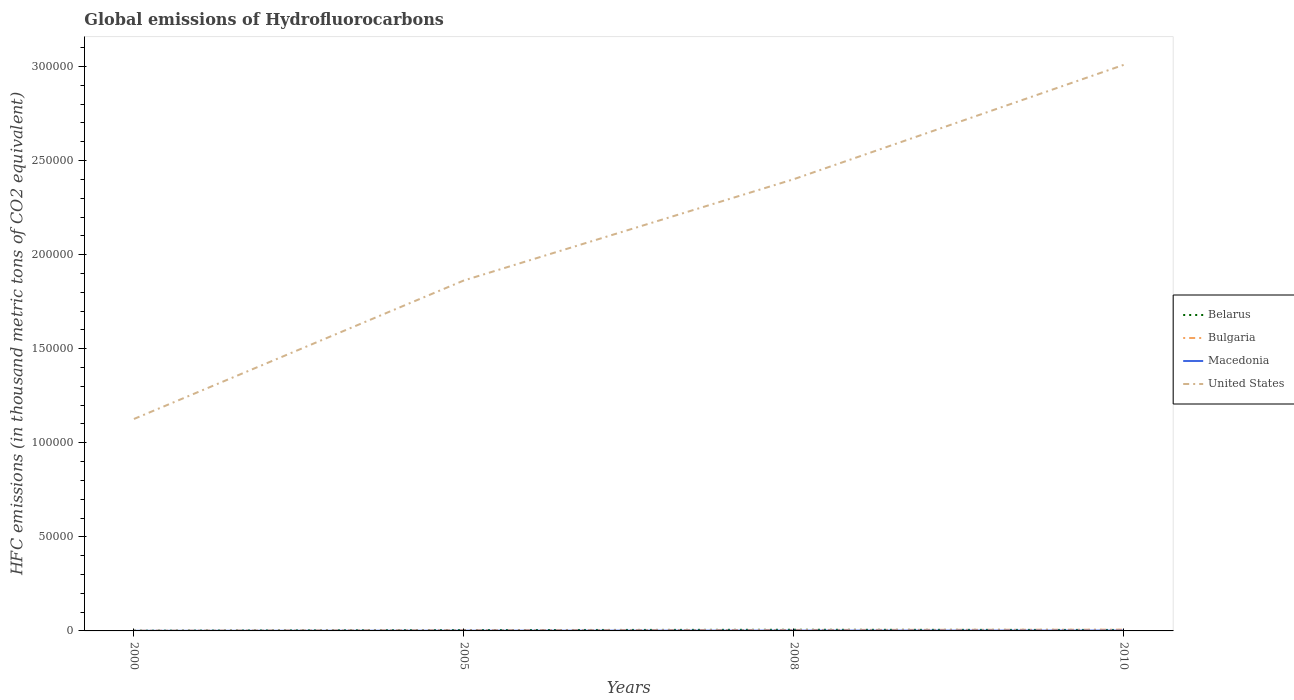How many different coloured lines are there?
Your response must be concise. 4. Across all years, what is the maximum global emissions of Hydrofluorocarbons in Bulgaria?
Provide a short and direct response. 103.1. What is the total global emissions of Hydrofluorocarbons in Macedonia in the graph?
Keep it short and to the point. -133.2. What is the difference between the highest and the second highest global emissions of Hydrofluorocarbons in Macedonia?
Make the answer very short. 133.2. What is the difference between the highest and the lowest global emissions of Hydrofluorocarbons in Belarus?
Make the answer very short. 3. Is the global emissions of Hydrofluorocarbons in United States strictly greater than the global emissions of Hydrofluorocarbons in Macedonia over the years?
Make the answer very short. No. How many years are there in the graph?
Your answer should be compact. 4. Are the values on the major ticks of Y-axis written in scientific E-notation?
Provide a succinct answer. No. Does the graph contain grids?
Ensure brevity in your answer.  No. How are the legend labels stacked?
Your response must be concise. Vertical. What is the title of the graph?
Your answer should be compact. Global emissions of Hydrofluorocarbons. What is the label or title of the X-axis?
Your response must be concise. Years. What is the label or title of the Y-axis?
Your answer should be very brief. HFC emissions (in thousand metric tons of CO2 equivalent). What is the HFC emissions (in thousand metric tons of CO2 equivalent) of Belarus in 2000?
Provide a short and direct response. 107.7. What is the HFC emissions (in thousand metric tons of CO2 equivalent) in Bulgaria in 2000?
Make the answer very short. 103.1. What is the HFC emissions (in thousand metric tons of CO2 equivalent) in Macedonia in 2000?
Offer a terse response. 51.8. What is the HFC emissions (in thousand metric tons of CO2 equivalent) of United States in 2000?
Give a very brief answer. 1.13e+05. What is the HFC emissions (in thousand metric tons of CO2 equivalent) of Belarus in 2005?
Offer a terse response. 440.2. What is the HFC emissions (in thousand metric tons of CO2 equivalent) in Bulgaria in 2005?
Your answer should be very brief. 361.6. What is the HFC emissions (in thousand metric tons of CO2 equivalent) of Macedonia in 2005?
Your answer should be compact. 119.1. What is the HFC emissions (in thousand metric tons of CO2 equivalent) of United States in 2005?
Keep it short and to the point. 1.86e+05. What is the HFC emissions (in thousand metric tons of CO2 equivalent) in Belarus in 2008?
Your response must be concise. 612.1. What is the HFC emissions (in thousand metric tons of CO2 equivalent) of Bulgaria in 2008?
Your answer should be very brief. 508. What is the HFC emissions (in thousand metric tons of CO2 equivalent) of Macedonia in 2008?
Offer a very short reply. 157.6. What is the HFC emissions (in thousand metric tons of CO2 equivalent) of United States in 2008?
Make the answer very short. 2.40e+05. What is the HFC emissions (in thousand metric tons of CO2 equivalent) in Belarus in 2010?
Your answer should be compact. 516. What is the HFC emissions (in thousand metric tons of CO2 equivalent) of Bulgaria in 2010?
Offer a terse response. 648. What is the HFC emissions (in thousand metric tons of CO2 equivalent) of Macedonia in 2010?
Your answer should be compact. 185. What is the HFC emissions (in thousand metric tons of CO2 equivalent) in United States in 2010?
Ensure brevity in your answer.  3.01e+05. Across all years, what is the maximum HFC emissions (in thousand metric tons of CO2 equivalent) of Belarus?
Your answer should be compact. 612.1. Across all years, what is the maximum HFC emissions (in thousand metric tons of CO2 equivalent) of Bulgaria?
Your answer should be very brief. 648. Across all years, what is the maximum HFC emissions (in thousand metric tons of CO2 equivalent) in Macedonia?
Ensure brevity in your answer.  185. Across all years, what is the maximum HFC emissions (in thousand metric tons of CO2 equivalent) in United States?
Keep it short and to the point. 3.01e+05. Across all years, what is the minimum HFC emissions (in thousand metric tons of CO2 equivalent) of Belarus?
Provide a short and direct response. 107.7. Across all years, what is the minimum HFC emissions (in thousand metric tons of CO2 equivalent) of Bulgaria?
Your answer should be very brief. 103.1. Across all years, what is the minimum HFC emissions (in thousand metric tons of CO2 equivalent) of Macedonia?
Your answer should be compact. 51.8. Across all years, what is the minimum HFC emissions (in thousand metric tons of CO2 equivalent) in United States?
Ensure brevity in your answer.  1.13e+05. What is the total HFC emissions (in thousand metric tons of CO2 equivalent) of Belarus in the graph?
Your answer should be very brief. 1676. What is the total HFC emissions (in thousand metric tons of CO2 equivalent) of Bulgaria in the graph?
Offer a very short reply. 1620.7. What is the total HFC emissions (in thousand metric tons of CO2 equivalent) of Macedonia in the graph?
Ensure brevity in your answer.  513.5. What is the total HFC emissions (in thousand metric tons of CO2 equivalent) in United States in the graph?
Offer a terse response. 8.40e+05. What is the difference between the HFC emissions (in thousand metric tons of CO2 equivalent) of Belarus in 2000 and that in 2005?
Provide a succinct answer. -332.5. What is the difference between the HFC emissions (in thousand metric tons of CO2 equivalent) in Bulgaria in 2000 and that in 2005?
Provide a short and direct response. -258.5. What is the difference between the HFC emissions (in thousand metric tons of CO2 equivalent) of Macedonia in 2000 and that in 2005?
Your answer should be very brief. -67.3. What is the difference between the HFC emissions (in thousand metric tons of CO2 equivalent) of United States in 2000 and that in 2005?
Give a very brief answer. -7.36e+04. What is the difference between the HFC emissions (in thousand metric tons of CO2 equivalent) in Belarus in 2000 and that in 2008?
Provide a short and direct response. -504.4. What is the difference between the HFC emissions (in thousand metric tons of CO2 equivalent) in Bulgaria in 2000 and that in 2008?
Offer a terse response. -404.9. What is the difference between the HFC emissions (in thousand metric tons of CO2 equivalent) of Macedonia in 2000 and that in 2008?
Your answer should be compact. -105.8. What is the difference between the HFC emissions (in thousand metric tons of CO2 equivalent) in United States in 2000 and that in 2008?
Your answer should be very brief. -1.27e+05. What is the difference between the HFC emissions (in thousand metric tons of CO2 equivalent) in Belarus in 2000 and that in 2010?
Your response must be concise. -408.3. What is the difference between the HFC emissions (in thousand metric tons of CO2 equivalent) in Bulgaria in 2000 and that in 2010?
Give a very brief answer. -544.9. What is the difference between the HFC emissions (in thousand metric tons of CO2 equivalent) in Macedonia in 2000 and that in 2010?
Your answer should be very brief. -133.2. What is the difference between the HFC emissions (in thousand metric tons of CO2 equivalent) of United States in 2000 and that in 2010?
Provide a succinct answer. -1.88e+05. What is the difference between the HFC emissions (in thousand metric tons of CO2 equivalent) of Belarus in 2005 and that in 2008?
Offer a very short reply. -171.9. What is the difference between the HFC emissions (in thousand metric tons of CO2 equivalent) in Bulgaria in 2005 and that in 2008?
Provide a succinct answer. -146.4. What is the difference between the HFC emissions (in thousand metric tons of CO2 equivalent) of Macedonia in 2005 and that in 2008?
Provide a succinct answer. -38.5. What is the difference between the HFC emissions (in thousand metric tons of CO2 equivalent) of United States in 2005 and that in 2008?
Keep it short and to the point. -5.38e+04. What is the difference between the HFC emissions (in thousand metric tons of CO2 equivalent) in Belarus in 2005 and that in 2010?
Offer a very short reply. -75.8. What is the difference between the HFC emissions (in thousand metric tons of CO2 equivalent) of Bulgaria in 2005 and that in 2010?
Your response must be concise. -286.4. What is the difference between the HFC emissions (in thousand metric tons of CO2 equivalent) of Macedonia in 2005 and that in 2010?
Keep it short and to the point. -65.9. What is the difference between the HFC emissions (in thousand metric tons of CO2 equivalent) in United States in 2005 and that in 2010?
Your answer should be compact. -1.15e+05. What is the difference between the HFC emissions (in thousand metric tons of CO2 equivalent) in Belarus in 2008 and that in 2010?
Provide a succinct answer. 96.1. What is the difference between the HFC emissions (in thousand metric tons of CO2 equivalent) in Bulgaria in 2008 and that in 2010?
Your answer should be very brief. -140. What is the difference between the HFC emissions (in thousand metric tons of CO2 equivalent) of Macedonia in 2008 and that in 2010?
Provide a short and direct response. -27.4. What is the difference between the HFC emissions (in thousand metric tons of CO2 equivalent) in United States in 2008 and that in 2010?
Provide a succinct answer. -6.08e+04. What is the difference between the HFC emissions (in thousand metric tons of CO2 equivalent) of Belarus in 2000 and the HFC emissions (in thousand metric tons of CO2 equivalent) of Bulgaria in 2005?
Keep it short and to the point. -253.9. What is the difference between the HFC emissions (in thousand metric tons of CO2 equivalent) of Belarus in 2000 and the HFC emissions (in thousand metric tons of CO2 equivalent) of Macedonia in 2005?
Keep it short and to the point. -11.4. What is the difference between the HFC emissions (in thousand metric tons of CO2 equivalent) of Belarus in 2000 and the HFC emissions (in thousand metric tons of CO2 equivalent) of United States in 2005?
Offer a very short reply. -1.86e+05. What is the difference between the HFC emissions (in thousand metric tons of CO2 equivalent) of Bulgaria in 2000 and the HFC emissions (in thousand metric tons of CO2 equivalent) of United States in 2005?
Keep it short and to the point. -1.86e+05. What is the difference between the HFC emissions (in thousand metric tons of CO2 equivalent) of Macedonia in 2000 and the HFC emissions (in thousand metric tons of CO2 equivalent) of United States in 2005?
Give a very brief answer. -1.86e+05. What is the difference between the HFC emissions (in thousand metric tons of CO2 equivalent) of Belarus in 2000 and the HFC emissions (in thousand metric tons of CO2 equivalent) of Bulgaria in 2008?
Provide a succinct answer. -400.3. What is the difference between the HFC emissions (in thousand metric tons of CO2 equivalent) of Belarus in 2000 and the HFC emissions (in thousand metric tons of CO2 equivalent) of Macedonia in 2008?
Provide a succinct answer. -49.9. What is the difference between the HFC emissions (in thousand metric tons of CO2 equivalent) of Belarus in 2000 and the HFC emissions (in thousand metric tons of CO2 equivalent) of United States in 2008?
Your answer should be very brief. -2.40e+05. What is the difference between the HFC emissions (in thousand metric tons of CO2 equivalent) of Bulgaria in 2000 and the HFC emissions (in thousand metric tons of CO2 equivalent) of Macedonia in 2008?
Provide a succinct answer. -54.5. What is the difference between the HFC emissions (in thousand metric tons of CO2 equivalent) in Bulgaria in 2000 and the HFC emissions (in thousand metric tons of CO2 equivalent) in United States in 2008?
Provide a short and direct response. -2.40e+05. What is the difference between the HFC emissions (in thousand metric tons of CO2 equivalent) of Macedonia in 2000 and the HFC emissions (in thousand metric tons of CO2 equivalent) of United States in 2008?
Make the answer very short. -2.40e+05. What is the difference between the HFC emissions (in thousand metric tons of CO2 equivalent) of Belarus in 2000 and the HFC emissions (in thousand metric tons of CO2 equivalent) of Bulgaria in 2010?
Provide a short and direct response. -540.3. What is the difference between the HFC emissions (in thousand metric tons of CO2 equivalent) in Belarus in 2000 and the HFC emissions (in thousand metric tons of CO2 equivalent) in Macedonia in 2010?
Provide a short and direct response. -77.3. What is the difference between the HFC emissions (in thousand metric tons of CO2 equivalent) of Belarus in 2000 and the HFC emissions (in thousand metric tons of CO2 equivalent) of United States in 2010?
Provide a succinct answer. -3.01e+05. What is the difference between the HFC emissions (in thousand metric tons of CO2 equivalent) in Bulgaria in 2000 and the HFC emissions (in thousand metric tons of CO2 equivalent) in Macedonia in 2010?
Keep it short and to the point. -81.9. What is the difference between the HFC emissions (in thousand metric tons of CO2 equivalent) of Bulgaria in 2000 and the HFC emissions (in thousand metric tons of CO2 equivalent) of United States in 2010?
Offer a terse response. -3.01e+05. What is the difference between the HFC emissions (in thousand metric tons of CO2 equivalent) in Macedonia in 2000 and the HFC emissions (in thousand metric tons of CO2 equivalent) in United States in 2010?
Provide a short and direct response. -3.01e+05. What is the difference between the HFC emissions (in thousand metric tons of CO2 equivalent) in Belarus in 2005 and the HFC emissions (in thousand metric tons of CO2 equivalent) in Bulgaria in 2008?
Provide a succinct answer. -67.8. What is the difference between the HFC emissions (in thousand metric tons of CO2 equivalent) in Belarus in 2005 and the HFC emissions (in thousand metric tons of CO2 equivalent) in Macedonia in 2008?
Provide a short and direct response. 282.6. What is the difference between the HFC emissions (in thousand metric tons of CO2 equivalent) in Belarus in 2005 and the HFC emissions (in thousand metric tons of CO2 equivalent) in United States in 2008?
Ensure brevity in your answer.  -2.40e+05. What is the difference between the HFC emissions (in thousand metric tons of CO2 equivalent) of Bulgaria in 2005 and the HFC emissions (in thousand metric tons of CO2 equivalent) of Macedonia in 2008?
Offer a terse response. 204. What is the difference between the HFC emissions (in thousand metric tons of CO2 equivalent) in Bulgaria in 2005 and the HFC emissions (in thousand metric tons of CO2 equivalent) in United States in 2008?
Ensure brevity in your answer.  -2.40e+05. What is the difference between the HFC emissions (in thousand metric tons of CO2 equivalent) of Macedonia in 2005 and the HFC emissions (in thousand metric tons of CO2 equivalent) of United States in 2008?
Give a very brief answer. -2.40e+05. What is the difference between the HFC emissions (in thousand metric tons of CO2 equivalent) in Belarus in 2005 and the HFC emissions (in thousand metric tons of CO2 equivalent) in Bulgaria in 2010?
Keep it short and to the point. -207.8. What is the difference between the HFC emissions (in thousand metric tons of CO2 equivalent) in Belarus in 2005 and the HFC emissions (in thousand metric tons of CO2 equivalent) in Macedonia in 2010?
Provide a succinct answer. 255.2. What is the difference between the HFC emissions (in thousand metric tons of CO2 equivalent) in Belarus in 2005 and the HFC emissions (in thousand metric tons of CO2 equivalent) in United States in 2010?
Provide a succinct answer. -3.00e+05. What is the difference between the HFC emissions (in thousand metric tons of CO2 equivalent) in Bulgaria in 2005 and the HFC emissions (in thousand metric tons of CO2 equivalent) in Macedonia in 2010?
Keep it short and to the point. 176.6. What is the difference between the HFC emissions (in thousand metric tons of CO2 equivalent) in Bulgaria in 2005 and the HFC emissions (in thousand metric tons of CO2 equivalent) in United States in 2010?
Provide a short and direct response. -3.01e+05. What is the difference between the HFC emissions (in thousand metric tons of CO2 equivalent) in Macedonia in 2005 and the HFC emissions (in thousand metric tons of CO2 equivalent) in United States in 2010?
Offer a very short reply. -3.01e+05. What is the difference between the HFC emissions (in thousand metric tons of CO2 equivalent) in Belarus in 2008 and the HFC emissions (in thousand metric tons of CO2 equivalent) in Bulgaria in 2010?
Offer a very short reply. -35.9. What is the difference between the HFC emissions (in thousand metric tons of CO2 equivalent) of Belarus in 2008 and the HFC emissions (in thousand metric tons of CO2 equivalent) of Macedonia in 2010?
Give a very brief answer. 427.1. What is the difference between the HFC emissions (in thousand metric tons of CO2 equivalent) in Belarus in 2008 and the HFC emissions (in thousand metric tons of CO2 equivalent) in United States in 2010?
Your answer should be very brief. -3.00e+05. What is the difference between the HFC emissions (in thousand metric tons of CO2 equivalent) in Bulgaria in 2008 and the HFC emissions (in thousand metric tons of CO2 equivalent) in Macedonia in 2010?
Ensure brevity in your answer.  323. What is the difference between the HFC emissions (in thousand metric tons of CO2 equivalent) of Bulgaria in 2008 and the HFC emissions (in thousand metric tons of CO2 equivalent) of United States in 2010?
Provide a short and direct response. -3.00e+05. What is the difference between the HFC emissions (in thousand metric tons of CO2 equivalent) in Macedonia in 2008 and the HFC emissions (in thousand metric tons of CO2 equivalent) in United States in 2010?
Offer a terse response. -3.01e+05. What is the average HFC emissions (in thousand metric tons of CO2 equivalent) of Belarus per year?
Your answer should be compact. 419. What is the average HFC emissions (in thousand metric tons of CO2 equivalent) of Bulgaria per year?
Your answer should be very brief. 405.18. What is the average HFC emissions (in thousand metric tons of CO2 equivalent) in Macedonia per year?
Provide a succinct answer. 128.38. What is the average HFC emissions (in thousand metric tons of CO2 equivalent) of United States per year?
Your answer should be very brief. 2.10e+05. In the year 2000, what is the difference between the HFC emissions (in thousand metric tons of CO2 equivalent) of Belarus and HFC emissions (in thousand metric tons of CO2 equivalent) of Macedonia?
Offer a terse response. 55.9. In the year 2000, what is the difference between the HFC emissions (in thousand metric tons of CO2 equivalent) in Belarus and HFC emissions (in thousand metric tons of CO2 equivalent) in United States?
Keep it short and to the point. -1.13e+05. In the year 2000, what is the difference between the HFC emissions (in thousand metric tons of CO2 equivalent) in Bulgaria and HFC emissions (in thousand metric tons of CO2 equivalent) in Macedonia?
Give a very brief answer. 51.3. In the year 2000, what is the difference between the HFC emissions (in thousand metric tons of CO2 equivalent) of Bulgaria and HFC emissions (in thousand metric tons of CO2 equivalent) of United States?
Make the answer very short. -1.13e+05. In the year 2000, what is the difference between the HFC emissions (in thousand metric tons of CO2 equivalent) in Macedonia and HFC emissions (in thousand metric tons of CO2 equivalent) in United States?
Provide a short and direct response. -1.13e+05. In the year 2005, what is the difference between the HFC emissions (in thousand metric tons of CO2 equivalent) of Belarus and HFC emissions (in thousand metric tons of CO2 equivalent) of Bulgaria?
Ensure brevity in your answer.  78.6. In the year 2005, what is the difference between the HFC emissions (in thousand metric tons of CO2 equivalent) in Belarus and HFC emissions (in thousand metric tons of CO2 equivalent) in Macedonia?
Keep it short and to the point. 321.1. In the year 2005, what is the difference between the HFC emissions (in thousand metric tons of CO2 equivalent) in Belarus and HFC emissions (in thousand metric tons of CO2 equivalent) in United States?
Make the answer very short. -1.86e+05. In the year 2005, what is the difference between the HFC emissions (in thousand metric tons of CO2 equivalent) in Bulgaria and HFC emissions (in thousand metric tons of CO2 equivalent) in Macedonia?
Provide a short and direct response. 242.5. In the year 2005, what is the difference between the HFC emissions (in thousand metric tons of CO2 equivalent) of Bulgaria and HFC emissions (in thousand metric tons of CO2 equivalent) of United States?
Offer a terse response. -1.86e+05. In the year 2005, what is the difference between the HFC emissions (in thousand metric tons of CO2 equivalent) of Macedonia and HFC emissions (in thousand metric tons of CO2 equivalent) of United States?
Make the answer very short. -1.86e+05. In the year 2008, what is the difference between the HFC emissions (in thousand metric tons of CO2 equivalent) of Belarus and HFC emissions (in thousand metric tons of CO2 equivalent) of Bulgaria?
Make the answer very short. 104.1. In the year 2008, what is the difference between the HFC emissions (in thousand metric tons of CO2 equivalent) in Belarus and HFC emissions (in thousand metric tons of CO2 equivalent) in Macedonia?
Your response must be concise. 454.5. In the year 2008, what is the difference between the HFC emissions (in thousand metric tons of CO2 equivalent) of Belarus and HFC emissions (in thousand metric tons of CO2 equivalent) of United States?
Your answer should be very brief. -2.40e+05. In the year 2008, what is the difference between the HFC emissions (in thousand metric tons of CO2 equivalent) of Bulgaria and HFC emissions (in thousand metric tons of CO2 equivalent) of Macedonia?
Provide a short and direct response. 350.4. In the year 2008, what is the difference between the HFC emissions (in thousand metric tons of CO2 equivalent) of Bulgaria and HFC emissions (in thousand metric tons of CO2 equivalent) of United States?
Offer a very short reply. -2.40e+05. In the year 2008, what is the difference between the HFC emissions (in thousand metric tons of CO2 equivalent) in Macedonia and HFC emissions (in thousand metric tons of CO2 equivalent) in United States?
Your response must be concise. -2.40e+05. In the year 2010, what is the difference between the HFC emissions (in thousand metric tons of CO2 equivalent) in Belarus and HFC emissions (in thousand metric tons of CO2 equivalent) in Bulgaria?
Keep it short and to the point. -132. In the year 2010, what is the difference between the HFC emissions (in thousand metric tons of CO2 equivalent) in Belarus and HFC emissions (in thousand metric tons of CO2 equivalent) in Macedonia?
Give a very brief answer. 331. In the year 2010, what is the difference between the HFC emissions (in thousand metric tons of CO2 equivalent) of Belarus and HFC emissions (in thousand metric tons of CO2 equivalent) of United States?
Provide a succinct answer. -3.00e+05. In the year 2010, what is the difference between the HFC emissions (in thousand metric tons of CO2 equivalent) of Bulgaria and HFC emissions (in thousand metric tons of CO2 equivalent) of Macedonia?
Offer a very short reply. 463. In the year 2010, what is the difference between the HFC emissions (in thousand metric tons of CO2 equivalent) in Bulgaria and HFC emissions (in thousand metric tons of CO2 equivalent) in United States?
Your response must be concise. -3.00e+05. In the year 2010, what is the difference between the HFC emissions (in thousand metric tons of CO2 equivalent) of Macedonia and HFC emissions (in thousand metric tons of CO2 equivalent) of United States?
Ensure brevity in your answer.  -3.01e+05. What is the ratio of the HFC emissions (in thousand metric tons of CO2 equivalent) in Belarus in 2000 to that in 2005?
Provide a succinct answer. 0.24. What is the ratio of the HFC emissions (in thousand metric tons of CO2 equivalent) in Bulgaria in 2000 to that in 2005?
Provide a succinct answer. 0.29. What is the ratio of the HFC emissions (in thousand metric tons of CO2 equivalent) in Macedonia in 2000 to that in 2005?
Offer a very short reply. 0.43. What is the ratio of the HFC emissions (in thousand metric tons of CO2 equivalent) of United States in 2000 to that in 2005?
Offer a terse response. 0.6. What is the ratio of the HFC emissions (in thousand metric tons of CO2 equivalent) of Belarus in 2000 to that in 2008?
Provide a short and direct response. 0.18. What is the ratio of the HFC emissions (in thousand metric tons of CO2 equivalent) in Bulgaria in 2000 to that in 2008?
Your answer should be compact. 0.2. What is the ratio of the HFC emissions (in thousand metric tons of CO2 equivalent) in Macedonia in 2000 to that in 2008?
Provide a short and direct response. 0.33. What is the ratio of the HFC emissions (in thousand metric tons of CO2 equivalent) of United States in 2000 to that in 2008?
Keep it short and to the point. 0.47. What is the ratio of the HFC emissions (in thousand metric tons of CO2 equivalent) of Belarus in 2000 to that in 2010?
Provide a succinct answer. 0.21. What is the ratio of the HFC emissions (in thousand metric tons of CO2 equivalent) of Bulgaria in 2000 to that in 2010?
Make the answer very short. 0.16. What is the ratio of the HFC emissions (in thousand metric tons of CO2 equivalent) of Macedonia in 2000 to that in 2010?
Provide a succinct answer. 0.28. What is the ratio of the HFC emissions (in thousand metric tons of CO2 equivalent) of United States in 2000 to that in 2010?
Provide a succinct answer. 0.37. What is the ratio of the HFC emissions (in thousand metric tons of CO2 equivalent) in Belarus in 2005 to that in 2008?
Your answer should be very brief. 0.72. What is the ratio of the HFC emissions (in thousand metric tons of CO2 equivalent) of Bulgaria in 2005 to that in 2008?
Make the answer very short. 0.71. What is the ratio of the HFC emissions (in thousand metric tons of CO2 equivalent) in Macedonia in 2005 to that in 2008?
Your answer should be very brief. 0.76. What is the ratio of the HFC emissions (in thousand metric tons of CO2 equivalent) of United States in 2005 to that in 2008?
Your answer should be compact. 0.78. What is the ratio of the HFC emissions (in thousand metric tons of CO2 equivalent) of Belarus in 2005 to that in 2010?
Keep it short and to the point. 0.85. What is the ratio of the HFC emissions (in thousand metric tons of CO2 equivalent) of Bulgaria in 2005 to that in 2010?
Make the answer very short. 0.56. What is the ratio of the HFC emissions (in thousand metric tons of CO2 equivalent) of Macedonia in 2005 to that in 2010?
Your answer should be compact. 0.64. What is the ratio of the HFC emissions (in thousand metric tons of CO2 equivalent) of United States in 2005 to that in 2010?
Keep it short and to the point. 0.62. What is the ratio of the HFC emissions (in thousand metric tons of CO2 equivalent) in Belarus in 2008 to that in 2010?
Provide a succinct answer. 1.19. What is the ratio of the HFC emissions (in thousand metric tons of CO2 equivalent) of Bulgaria in 2008 to that in 2010?
Make the answer very short. 0.78. What is the ratio of the HFC emissions (in thousand metric tons of CO2 equivalent) of Macedonia in 2008 to that in 2010?
Offer a terse response. 0.85. What is the ratio of the HFC emissions (in thousand metric tons of CO2 equivalent) of United States in 2008 to that in 2010?
Offer a terse response. 0.8. What is the difference between the highest and the second highest HFC emissions (in thousand metric tons of CO2 equivalent) of Belarus?
Ensure brevity in your answer.  96.1. What is the difference between the highest and the second highest HFC emissions (in thousand metric tons of CO2 equivalent) in Bulgaria?
Your response must be concise. 140. What is the difference between the highest and the second highest HFC emissions (in thousand metric tons of CO2 equivalent) of Macedonia?
Give a very brief answer. 27.4. What is the difference between the highest and the second highest HFC emissions (in thousand metric tons of CO2 equivalent) in United States?
Give a very brief answer. 6.08e+04. What is the difference between the highest and the lowest HFC emissions (in thousand metric tons of CO2 equivalent) of Belarus?
Make the answer very short. 504.4. What is the difference between the highest and the lowest HFC emissions (in thousand metric tons of CO2 equivalent) in Bulgaria?
Give a very brief answer. 544.9. What is the difference between the highest and the lowest HFC emissions (in thousand metric tons of CO2 equivalent) of Macedonia?
Give a very brief answer. 133.2. What is the difference between the highest and the lowest HFC emissions (in thousand metric tons of CO2 equivalent) in United States?
Provide a succinct answer. 1.88e+05. 